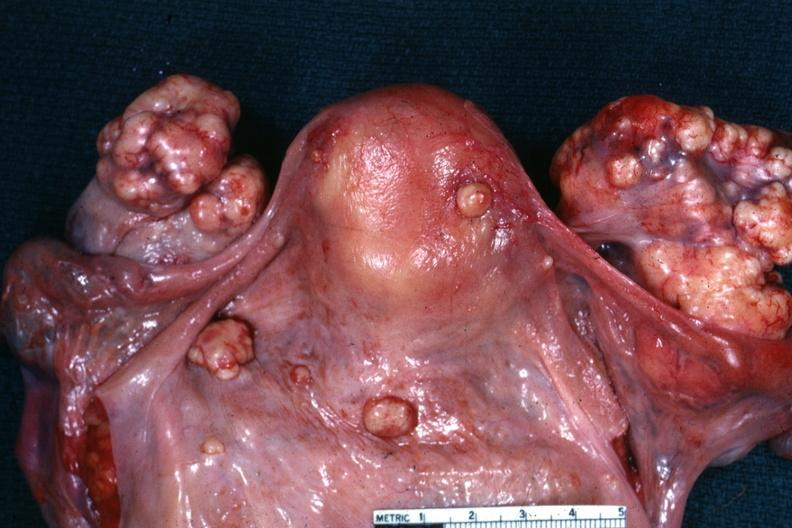does this image show view of uterus tubes and ovaries showing large nodular metastatic tumor masses on ovaries?
Answer the question using a single word or phrase. Yes 